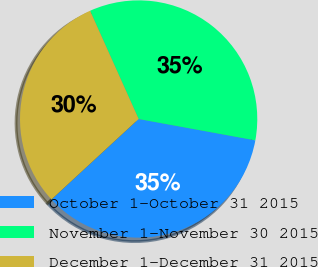Convert chart. <chart><loc_0><loc_0><loc_500><loc_500><pie_chart><fcel>October 1-October 31 2015<fcel>November 1-November 30 2015<fcel>December 1-December 31 2015<nl><fcel>35.26%<fcel>34.59%<fcel>30.15%<nl></chart> 